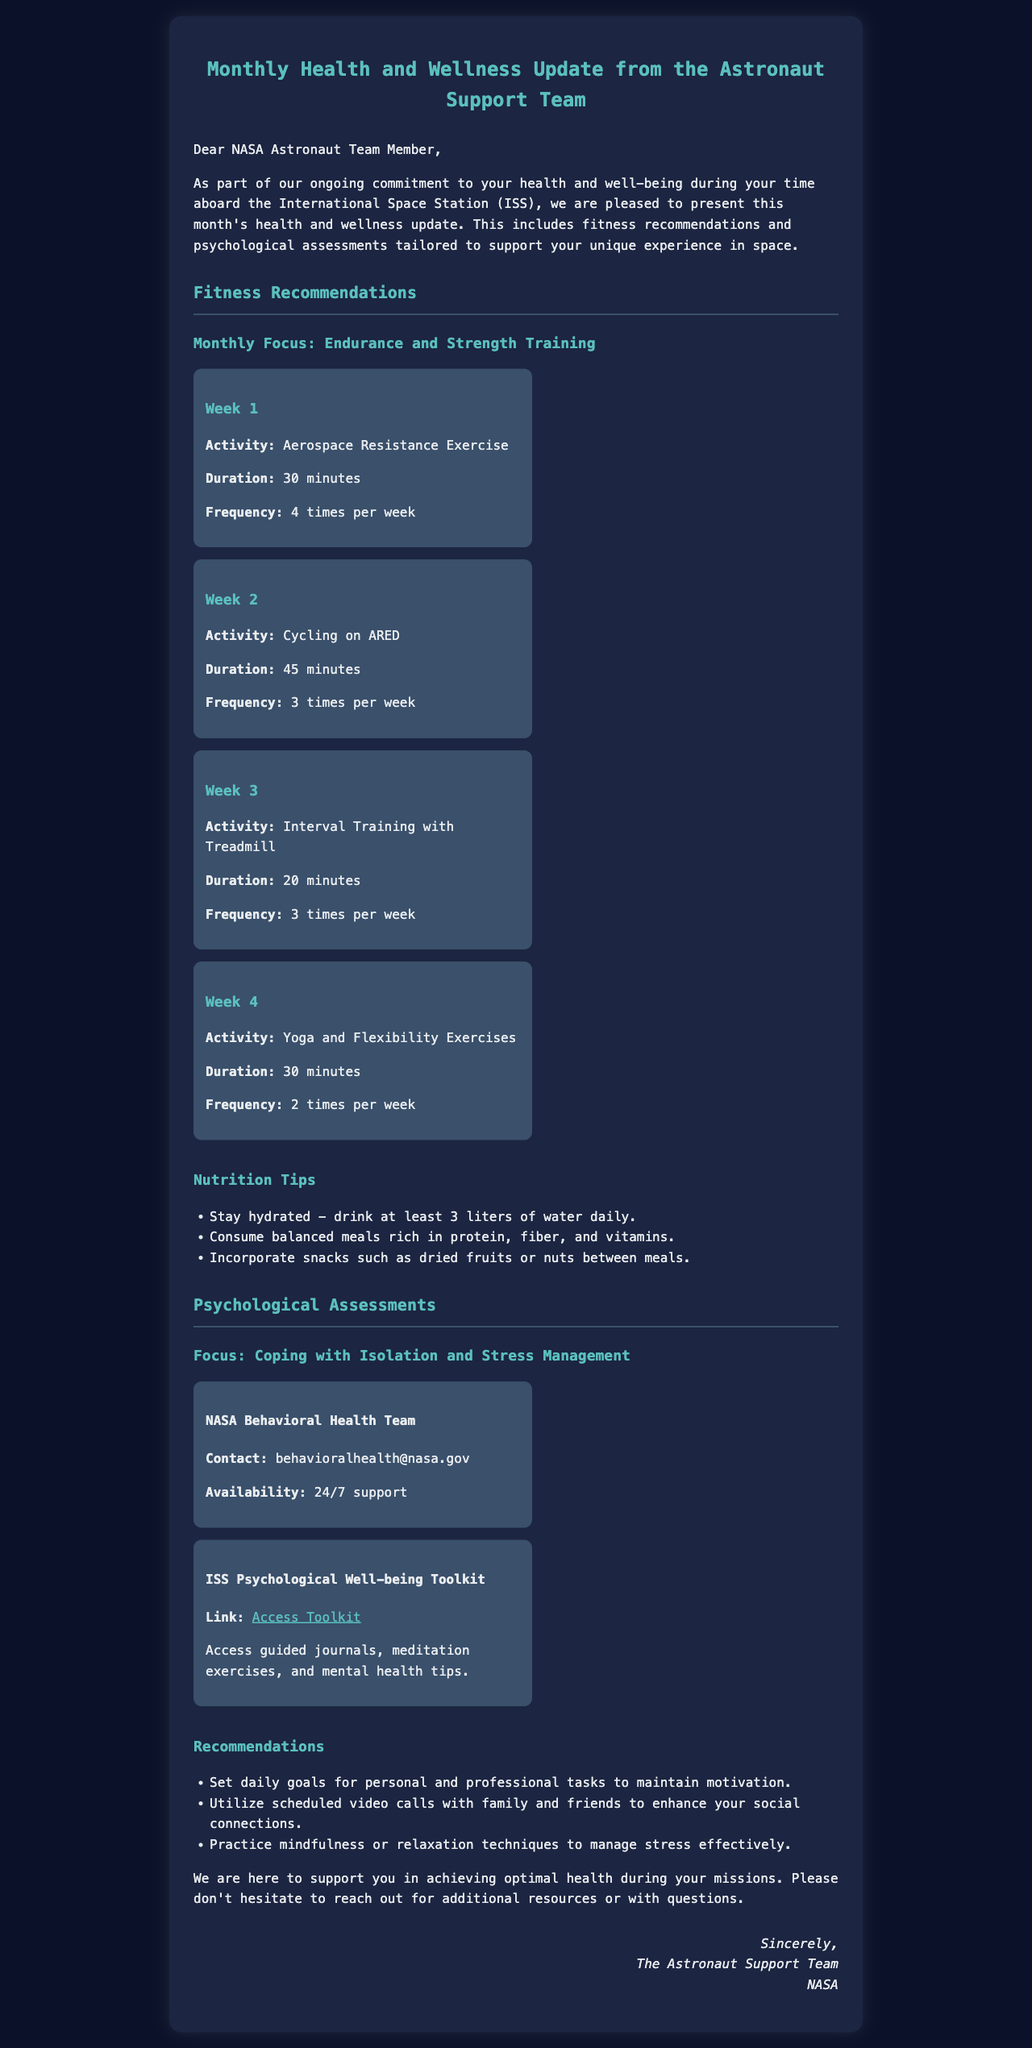What is the focus of this month's fitness recommendations? The focus of this month's fitness recommendations is on endurance and strength training.
Answer: Endurance and strength training How many times a week should I perform Aerospace Resistance Exercise? Aerospace Resistance Exercise should be performed 4 times per week as indicated in the document.
Answer: 4 times per week What is the duration for the Yoga and Flexibility Exercises in Week 4? The duration for Yoga and Flexibility Exercises in Week 4 is 30 minutes.
Answer: 30 minutes What should one consume between meals as snacks? The document suggests incorporating snacks such as dried fruits or nuts between meals.
Answer: Dried fruits or nuts How can I contact the NASA Behavioral Health Team? The document provides the contact email for the NASA Behavioral Health Team as behavioralhealth@nasa.gov.
Answer: behavioralhealth@nasa.gov Why is it important to set daily goals according to the recommendations? Setting daily goals helps maintain motivation and is suggested in the document as a way to cope with isolation.
Answer: Maintain motivation What resource provides 24/7 support? The NASA Behavioral Health Team offers 24/7 support as stated in the document.
Answer: NASA Behavioral Health Team What is an activity included in Week 3's exercise schedule? An activity included in Week 3's exercise schedule is Interval Training with Treadmill.
Answer: Interval Training with Treadmill Where can I access the ISS Psychological Well-being Toolkit? The ISS Psychological Well-being Toolkit can be accessed via the link provided, which is https://www.nasa.gov/ISSpsychtoolkit.
Answer: https://www.nasa.gov/ISSpsychtoolkit What is one of the nutrition tips mentioned in the update? One of the nutrition tips mentioned is to stay hydrated by drinking at least 3 liters of water daily.
Answer: Drink at least 3 liters of water daily 